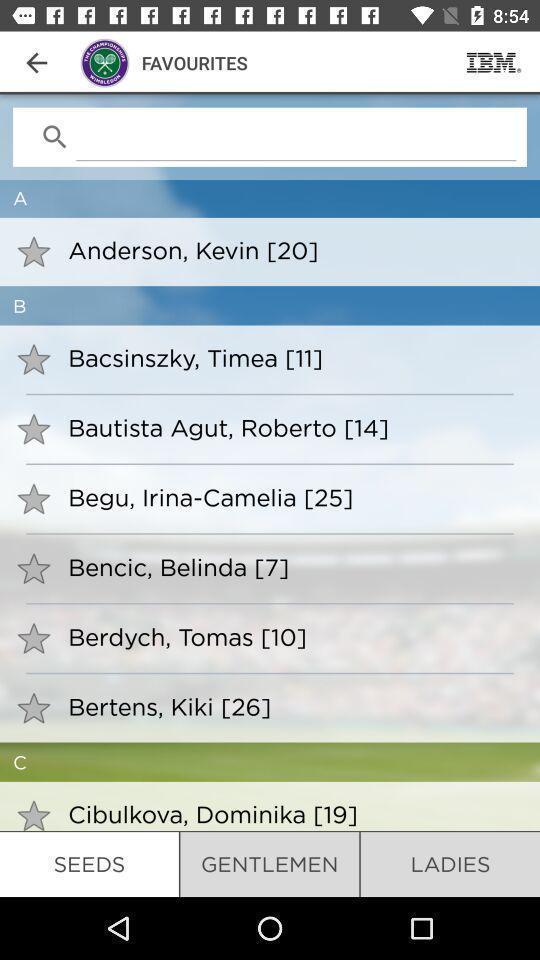Describe the visual elements of this screenshot. Search with different person in favourites option. 